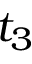<formula> <loc_0><loc_0><loc_500><loc_500>t _ { 3 }</formula> 